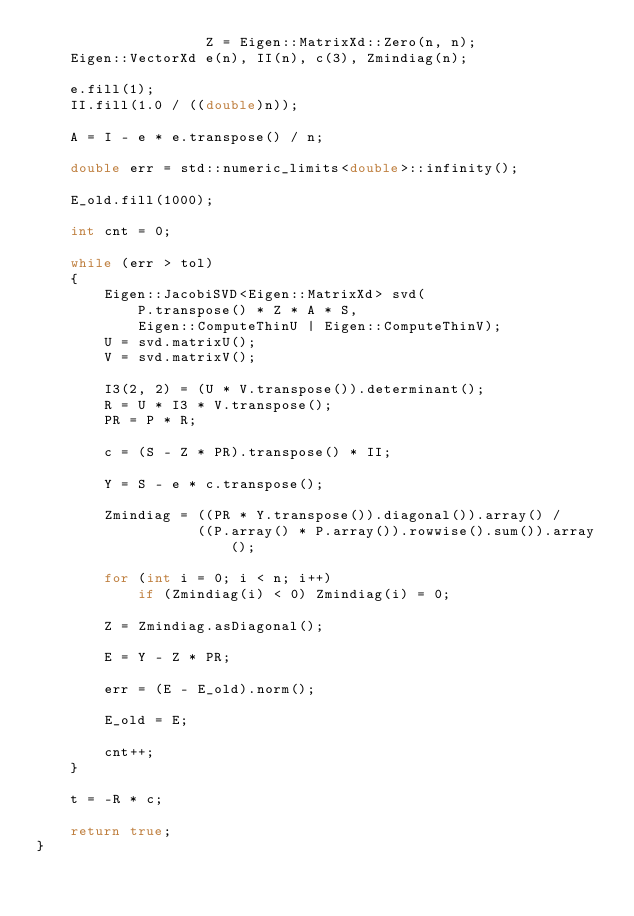<code> <loc_0><loc_0><loc_500><loc_500><_C++_>					Z = Eigen::MatrixXd::Zero(n, n);
	Eigen::VectorXd e(n), II(n), c(3), Zmindiag(n);

	e.fill(1);
	II.fill(1.0 / ((double)n));

	A = I - e * e.transpose() / n;

	double err = std::numeric_limits<double>::infinity();

	E_old.fill(1000);

	int cnt = 0;

	while (err > tol)
	{
		Eigen::JacobiSVD<Eigen::MatrixXd> svd(
			P.transpose() * Z * A * S,
			Eigen::ComputeThinU | Eigen::ComputeThinV);
		U = svd.matrixU();
		V = svd.matrixV();

		I3(2, 2) = (U * V.transpose()).determinant();
		R = U * I3 * V.transpose();
		PR = P * R;

		c = (S - Z * PR).transpose() * II;

		Y = S - e * c.transpose();

		Zmindiag = ((PR * Y.transpose()).diagonal()).array() /
				   ((P.array() * P.array()).rowwise().sum()).array();

		for (int i = 0; i < n; i++)
			if (Zmindiag(i) < 0) Zmindiag(i) = 0;

		Z = Zmindiag.asDiagonal();

		E = Y - Z * PR;

		err = (E - E_old).norm();

		E_old = E;

		cnt++;
	}

	t = -R * c;

	return true;
}
</code> 